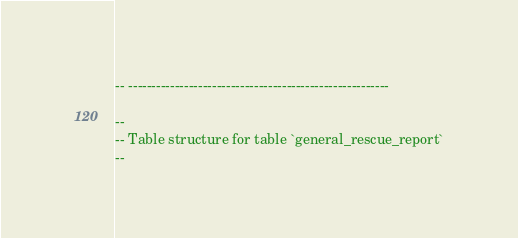<code> <loc_0><loc_0><loc_500><loc_500><_SQL_>
-- --------------------------------------------------------

--
-- Table structure for table `general_rescue_report`
--
</code> 